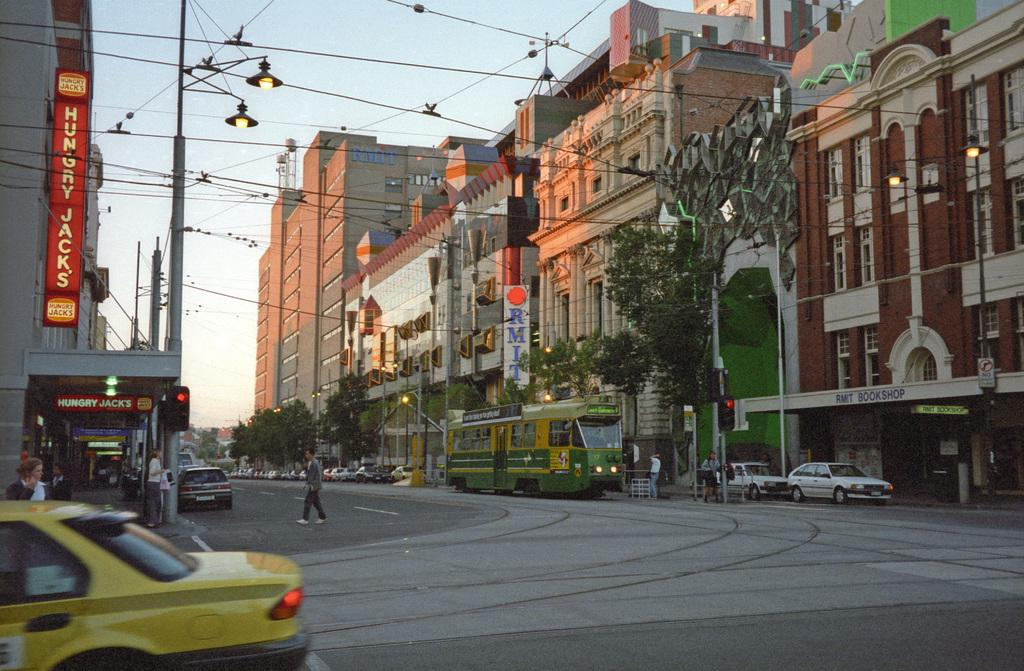<image>
Render a clear and concise summary of the photo. The sign on the left of the street in red is for Hungry Jacks. 